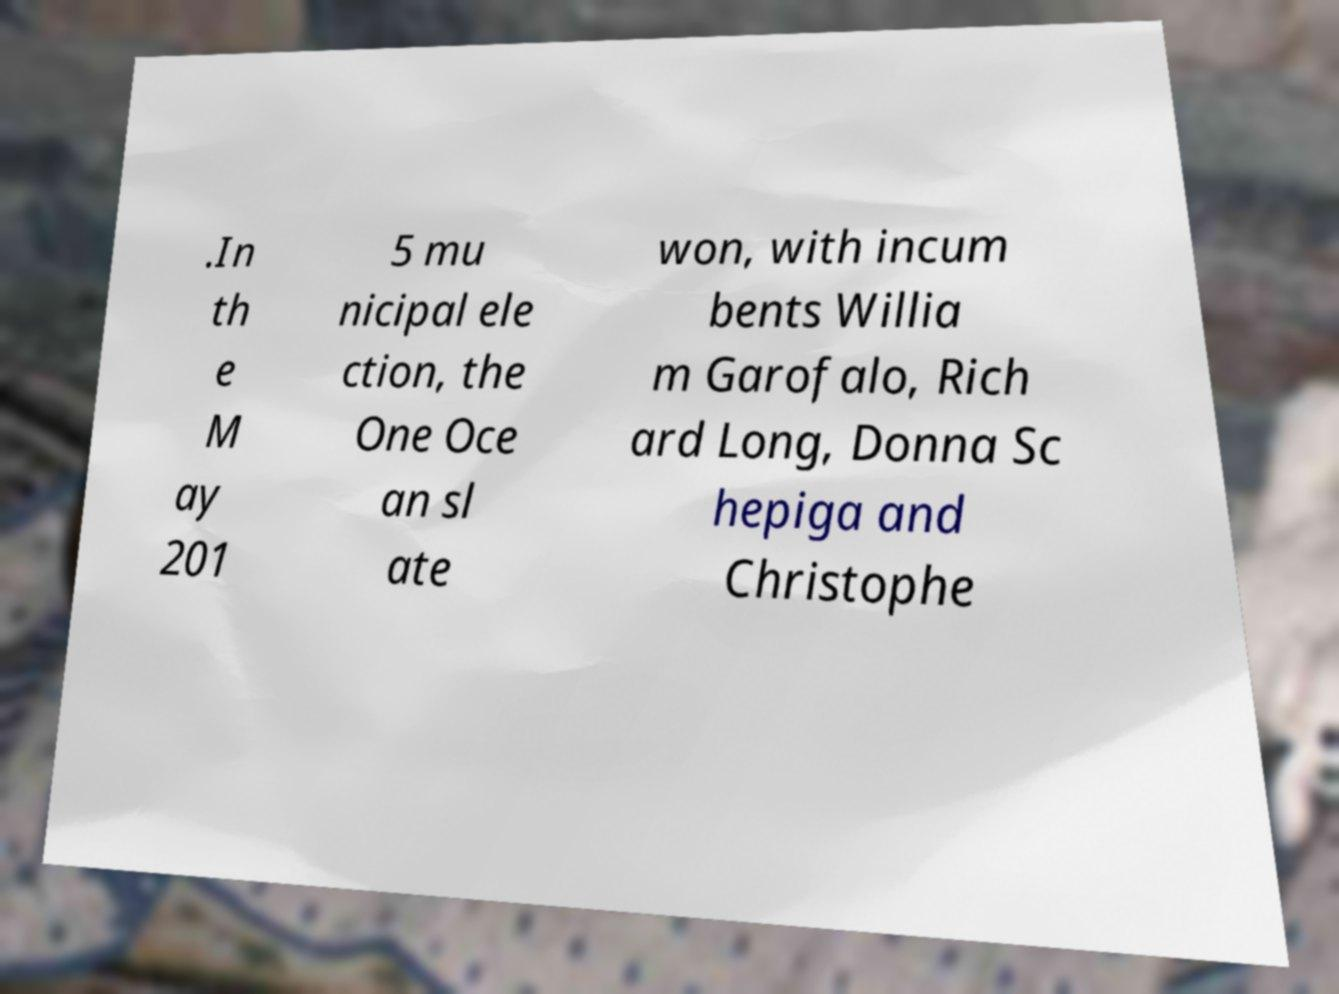Please identify and transcribe the text found in this image. .In th e M ay 201 5 mu nicipal ele ction, the One Oce an sl ate won, with incum bents Willia m Garofalo, Rich ard Long, Donna Sc hepiga and Christophe 